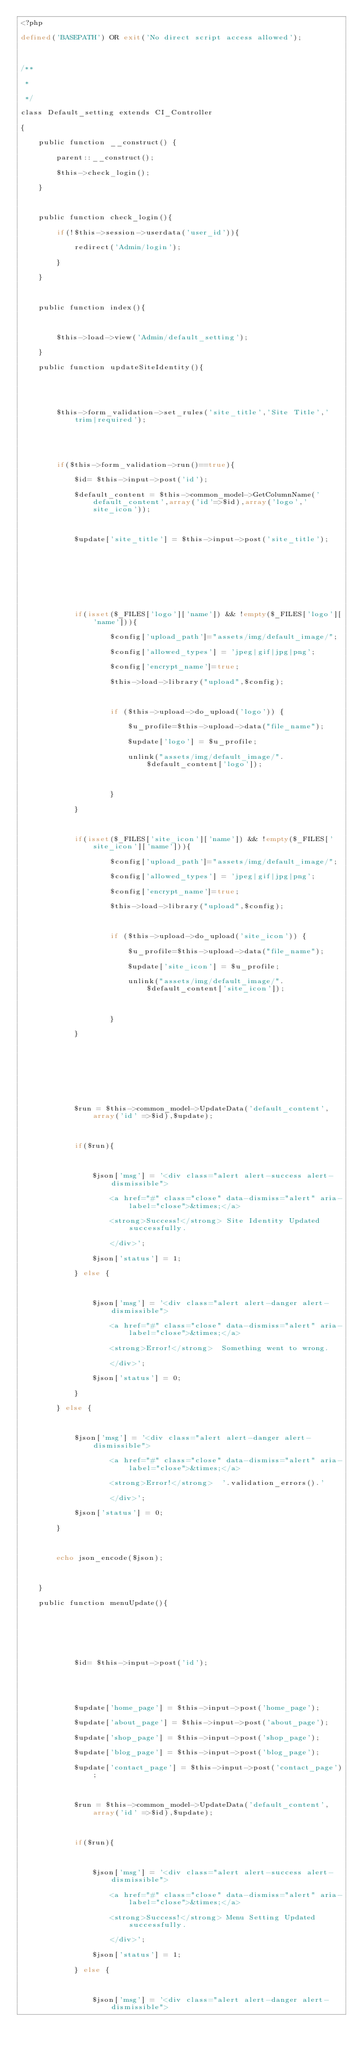Convert code to text. <code><loc_0><loc_0><loc_500><loc_500><_PHP_><?php

defined('BASEPATH') OR exit('No direct script access allowed');



/**

 * 

 */

class Default_setting extends CI_Controller

{

	public function __construct() {

		parent::__construct();

		$this->check_login();

	}

	

	public function check_login(){

		if(!$this->session->userdata('user_id')){

			redirect('Admin/login');

		}

	}

	

	public function index(){

		

		$this->load->view('Admin/default_setting');

	}

	public function updateSiteIdentity(){

		

		

		$this->form_validation->set_rules('site_title','Site Title','trim|required');

 		



 		if($this->form_validation->run()==true){

 			$id= $this->input->post('id');

			$default_content = $this->common_model->GetColumnName('default_content',array('id'=>$id),array('logo','site_icon')); 

			

			$update['site_title'] = $this->input->post('site_title');

			

            

            



			if(isset($_FILES['logo']['name']) && !empty($_FILES['logo']['name'])){

					$config['upload_path']="assets/img/default_image/";

					$config['allowed_types'] = 'jpeg|gif|jpg|png';

					$config['encrypt_name']=true;

					$this->load->library("upload",$config);

					

					if ($this->upload->do_upload('logo')) {

						$u_profile=$this->upload->data("file_name");

						$update['logo'] = $u_profile;

						unlink("assets/img/default_image/".$default_content['logo']);

						

					}

		    }



		    if(isset($_FILES['site_icon']['name']) && !empty($_FILES['site_icon']['name'])){

					$config['upload_path']="assets/img/default_image/";

					$config['allowed_types'] = 'jpeg|gif|jpg|png';

					$config['encrypt_name']=true;

					$this->load->library("upload",$config);

					

					if ($this->upload->do_upload('site_icon')) {

						$u_profile=$this->upload->data("file_name");

						$update['site_icon'] = $u_profile;

						unlink("assets/img/default_image/".$default_content['site_icon']);

						

					}

		    }



			



			

			$run = $this->common_model->UpdateData('default_content',array('id' =>$id),$update);



			if($run){

				

				$json['msg'] = '<div class="alert alert-success alert-dismissible">

					<a href="#" class="close" data-dismiss="alert" aria-label="close">&times;</a>

					<strong>Success!</strong> Site Identity Updated successfully.

					</div>';

				$json['status'] = 1;

			} else {

				

				$json['msg'] = '<div class="alert alert-danger alert-dismissible">

					<a href="#" class="close" data-dismiss="alert" aria-label="close">&times;</a>

					<strong>Error!</strong>  Something went to wrong.

					</div>';

				$json['status'] = 0;

			}

		} else {

			

			$json['msg'] = '<div class="alert alert-danger alert-dismissible">

					<a href="#" class="close" data-dismiss="alert" aria-label="close">&times;</a>

					<strong>Error!</strong>  '.validation_errors().'

					</div>';

			$json['status'] = 0;

		}



		echo json_encode($json);



 	}

 	public function menuUpdate(){

		

		

		

 			$id= $this->input->post('id');

			 

			

			$update['home_page'] = $this->input->post('home_page');

			$update['about_page'] = $this->input->post('about_page');

			$update['shop_page'] = $this->input->post('shop_page');

			$update['blog_page'] = $this->input->post('blog_page');

			$update['contact_page'] = $this->input->post('contact_page');

			

            $run = $this->common_model->UpdateData('default_content',array('id' =>$id),$update);



			if($run){

				

				$json['msg'] = '<div class="alert alert-success alert-dismissible">

					<a href="#" class="close" data-dismiss="alert" aria-label="close">&times;</a>

					<strong>Success!</strong> Menu Setting Updated successfully.

					</div>';

				$json['status'] = 1;

			} else {

				

				$json['msg'] = '<div class="alert alert-danger alert-dismissible">
</code> 